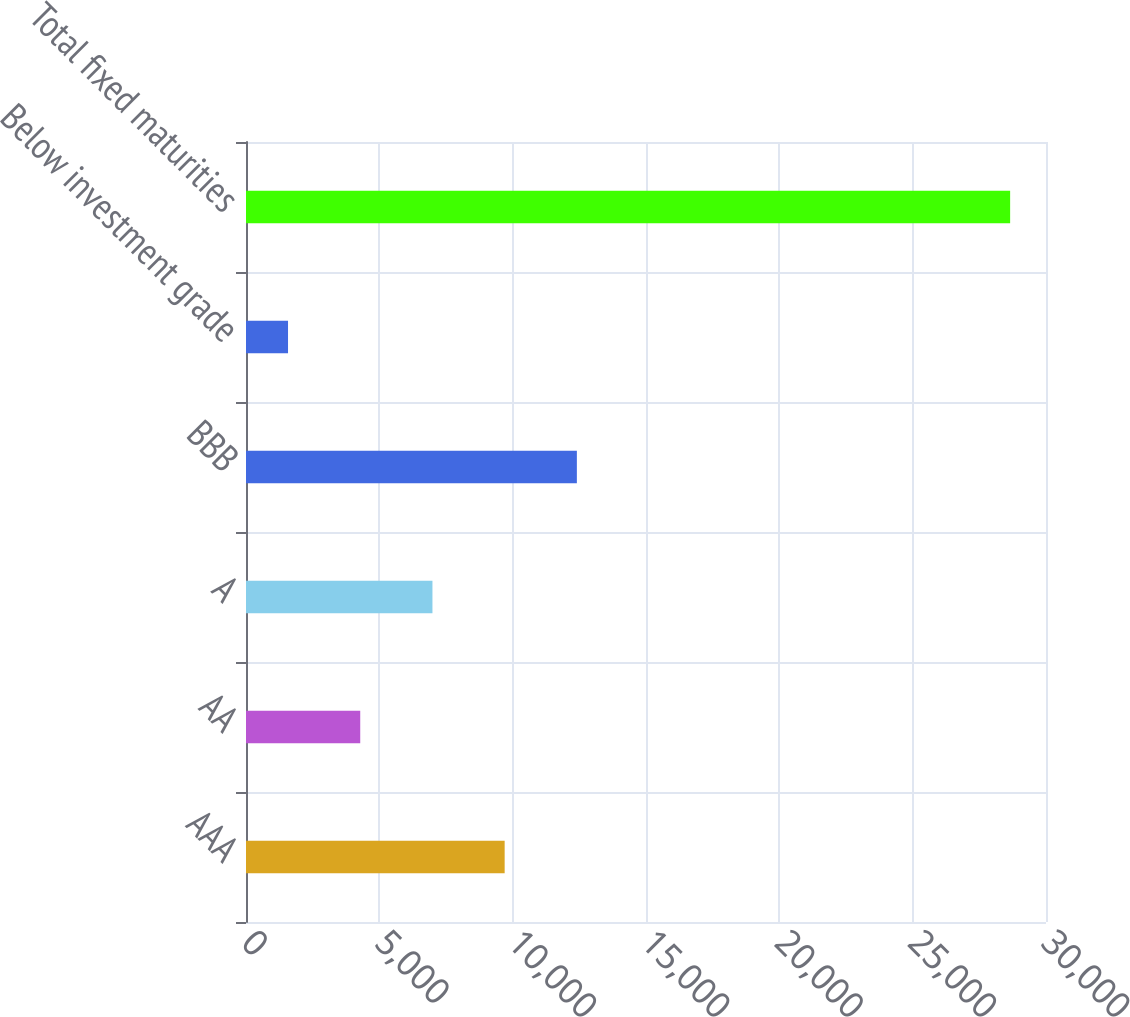Convert chart. <chart><loc_0><loc_0><loc_500><loc_500><bar_chart><fcel>AAA<fcel>AA<fcel>A<fcel>BBB<fcel>Below investment grade<fcel>Total fixed maturities<nl><fcel>9699.7<fcel>4283.9<fcel>6991.8<fcel>12407.6<fcel>1576<fcel>28655<nl></chart> 